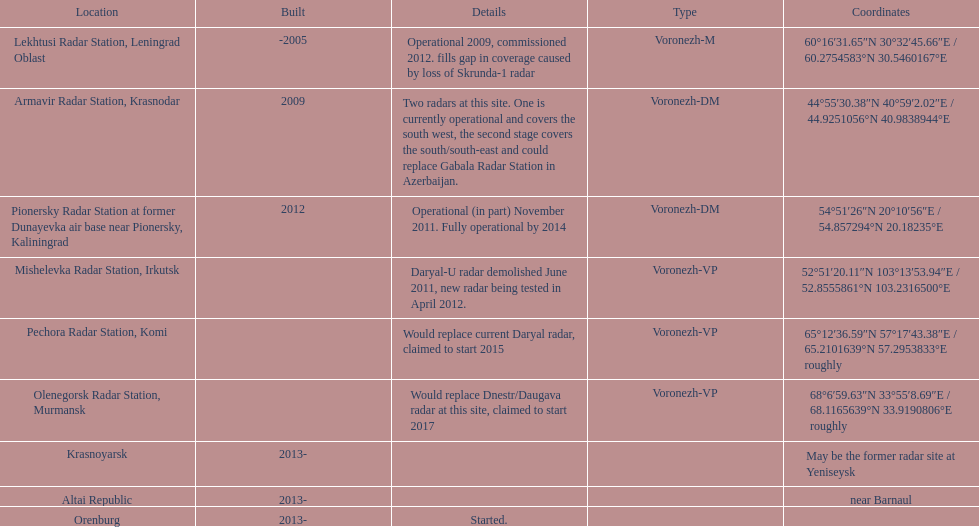What is the only radar that will start in 2015? Pechora Radar Station, Komi. 